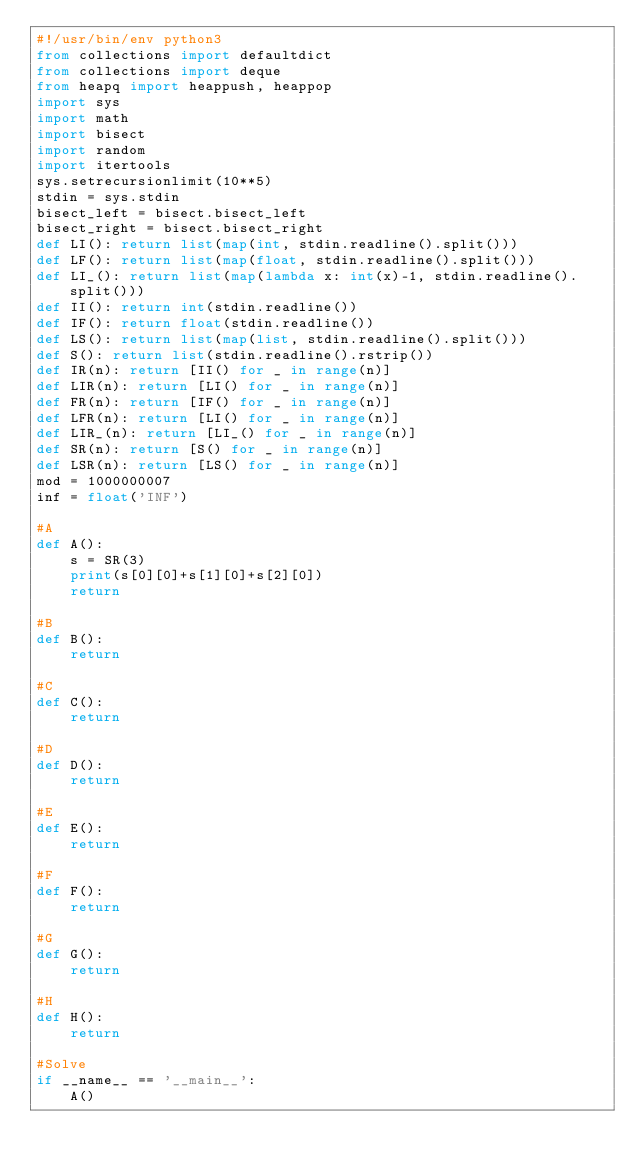Convert code to text. <code><loc_0><loc_0><loc_500><loc_500><_Python_>#!/usr/bin/env python3
from collections import defaultdict
from collections import deque
from heapq import heappush, heappop
import sys
import math
import bisect
import random
import itertools
sys.setrecursionlimit(10**5)
stdin = sys.stdin
bisect_left = bisect.bisect_left
bisect_right = bisect.bisect_right
def LI(): return list(map(int, stdin.readline().split()))
def LF(): return list(map(float, stdin.readline().split()))
def LI_(): return list(map(lambda x: int(x)-1, stdin.readline().split()))
def II(): return int(stdin.readline())
def IF(): return float(stdin.readline())
def LS(): return list(map(list, stdin.readline().split()))
def S(): return list(stdin.readline().rstrip())
def IR(n): return [II() for _ in range(n)]
def LIR(n): return [LI() for _ in range(n)]
def FR(n): return [IF() for _ in range(n)]
def LFR(n): return [LI() for _ in range(n)]
def LIR_(n): return [LI_() for _ in range(n)]
def SR(n): return [S() for _ in range(n)]
def LSR(n): return [LS() for _ in range(n)]
mod = 1000000007
inf = float('INF')

#A
def A():
    s = SR(3)
    print(s[0][0]+s[1][0]+s[2][0])
    return

#B
def B():
    return

#C
def C():
    return

#D
def D():
    return

#E
def E():
    return

#F
def F():
    return

#G
def G():
    return

#H
def H():
    return

#Solve
if __name__ == '__main__':
    A()
</code> 